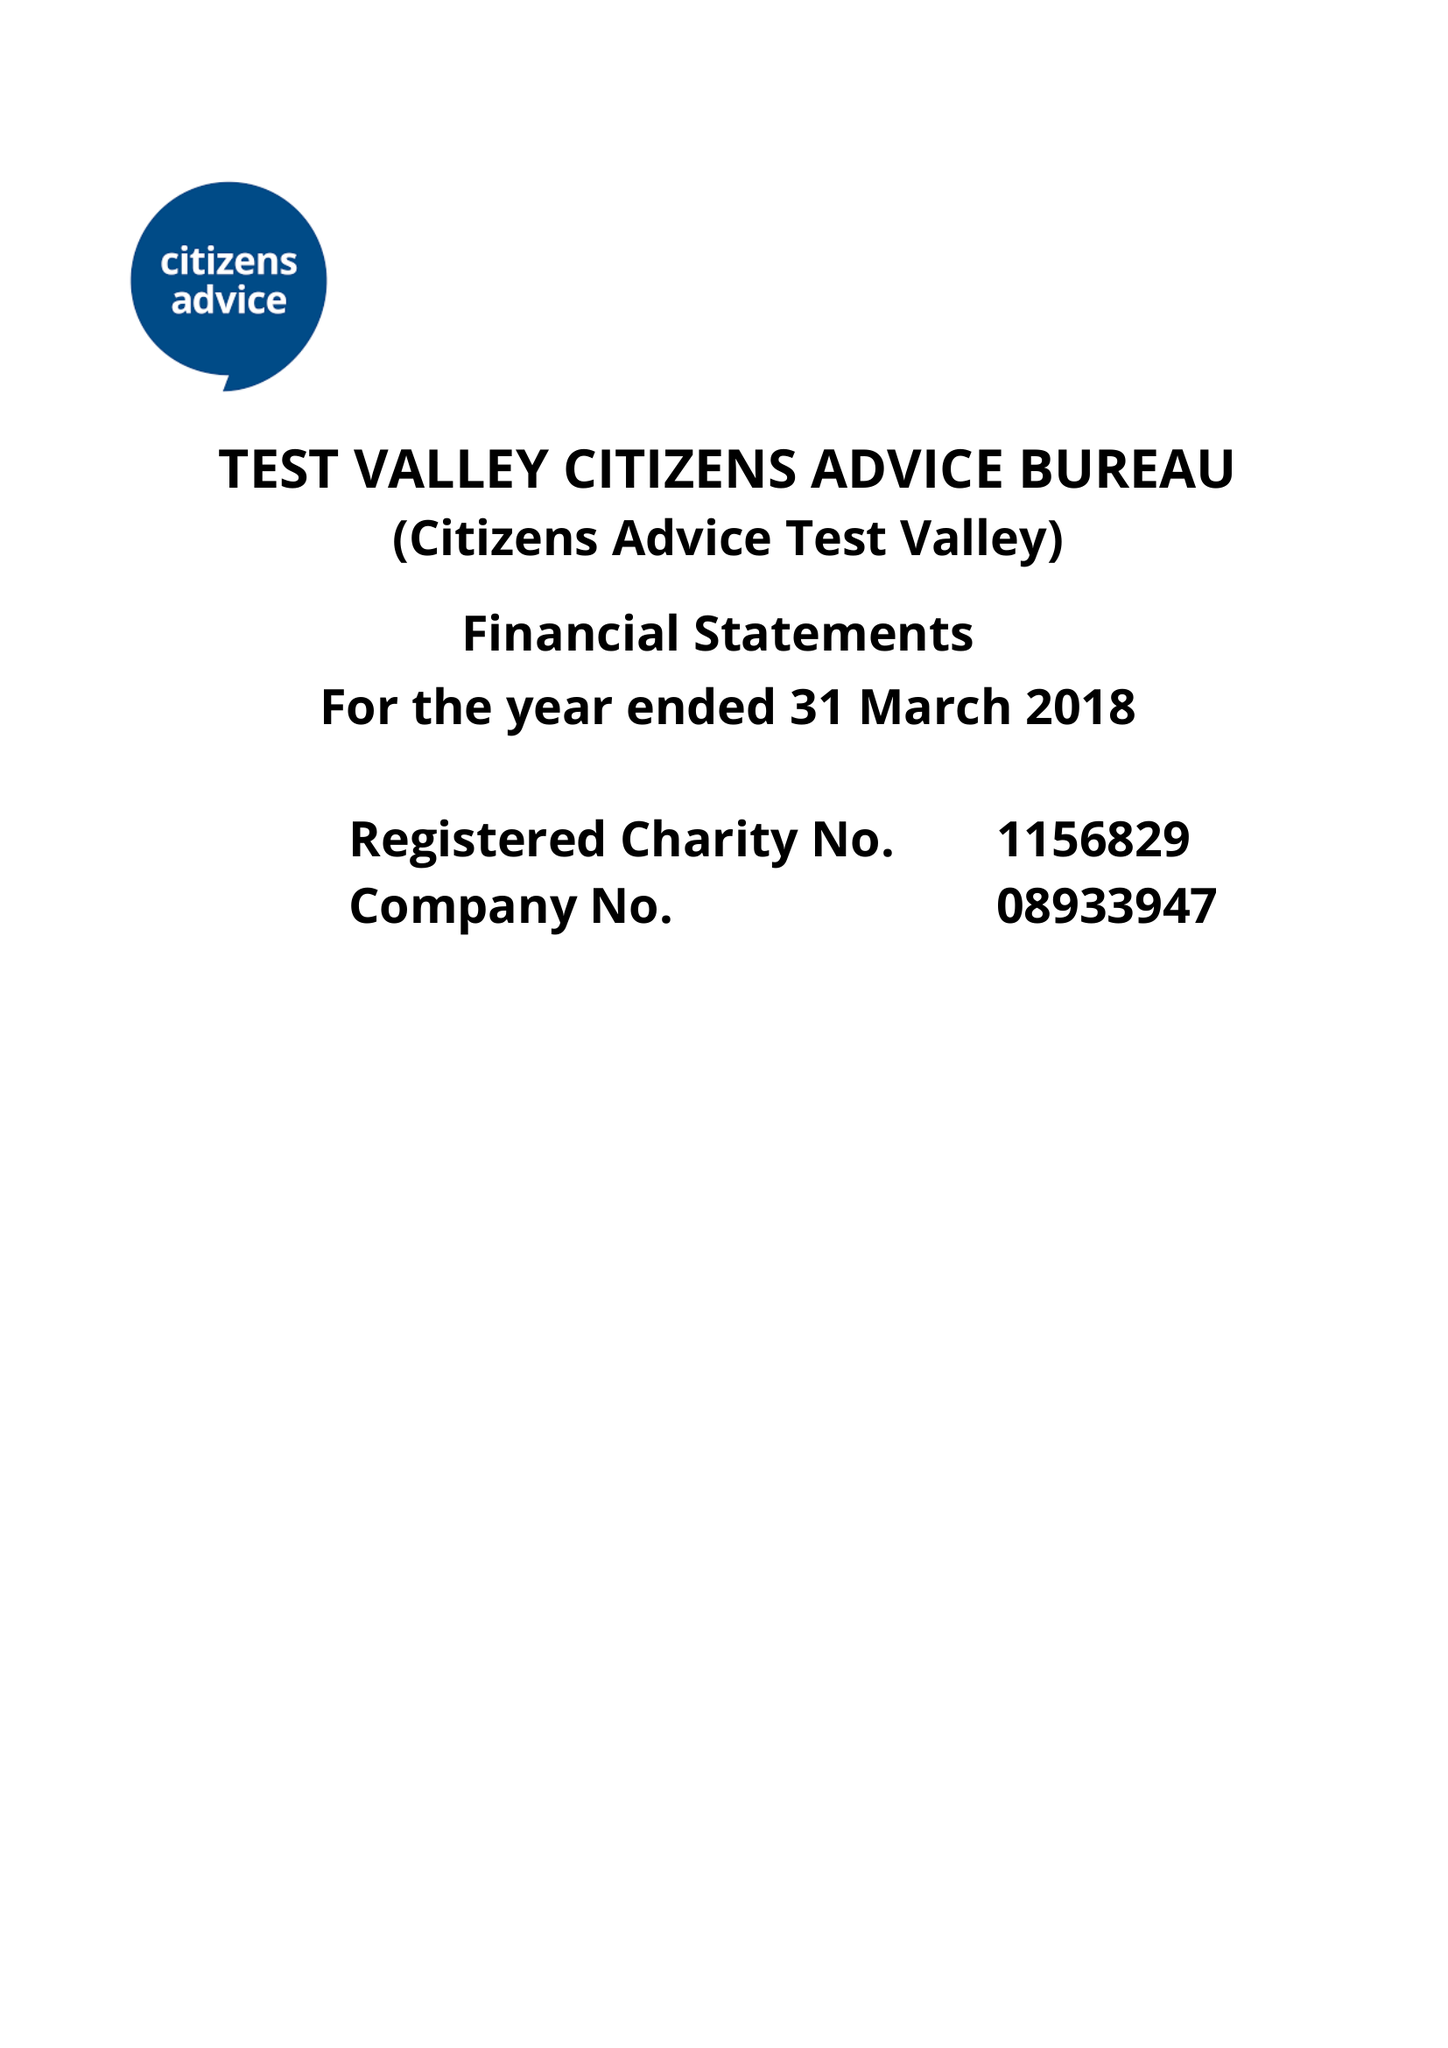What is the value for the address__postcode?
Answer the question using a single word or phrase. SP10 2NU 